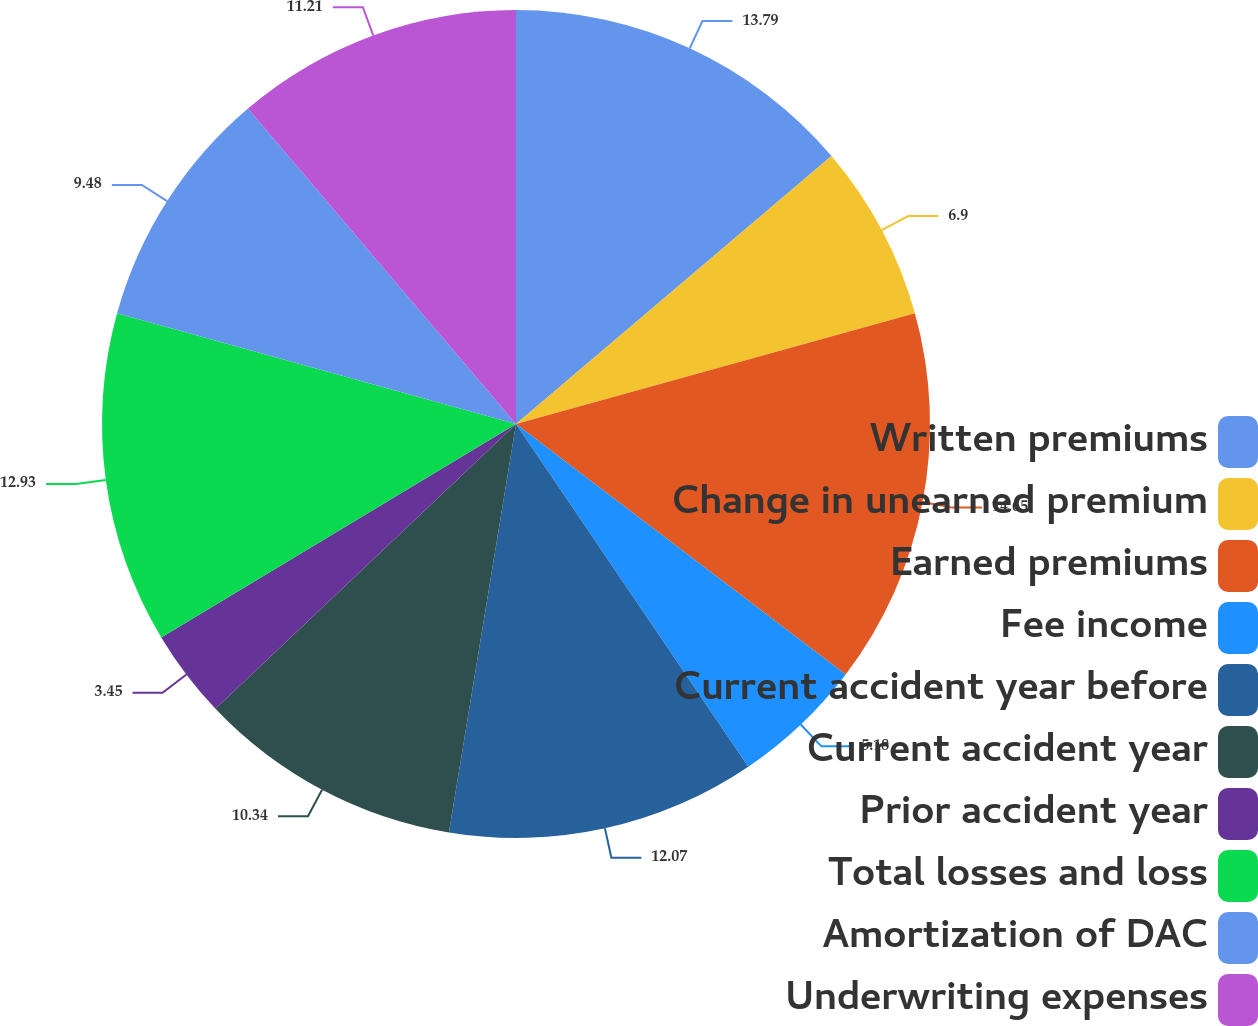<chart> <loc_0><loc_0><loc_500><loc_500><pie_chart><fcel>Written premiums<fcel>Change in unearned premium<fcel>Earned premiums<fcel>Fee income<fcel>Current accident year before<fcel>Current accident year<fcel>Prior accident year<fcel>Total losses and loss<fcel>Amortization of DAC<fcel>Underwriting expenses<nl><fcel>13.79%<fcel>6.9%<fcel>14.65%<fcel>5.18%<fcel>12.07%<fcel>10.34%<fcel>3.45%<fcel>12.93%<fcel>9.48%<fcel>11.21%<nl></chart> 